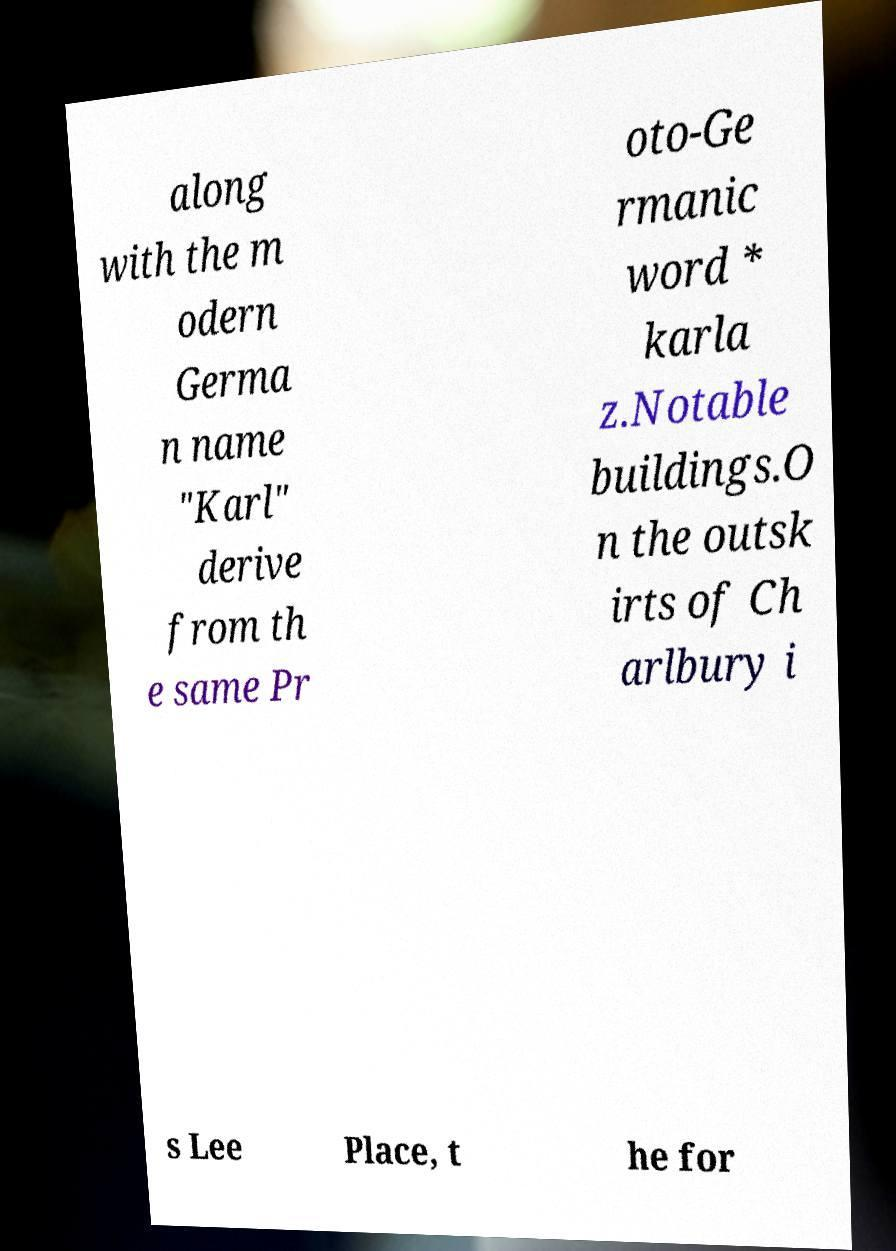Please read and relay the text visible in this image. What does it say? along with the m odern Germa n name "Karl" derive from th e same Pr oto-Ge rmanic word * karla z.Notable buildings.O n the outsk irts of Ch arlbury i s Lee Place, t he for 